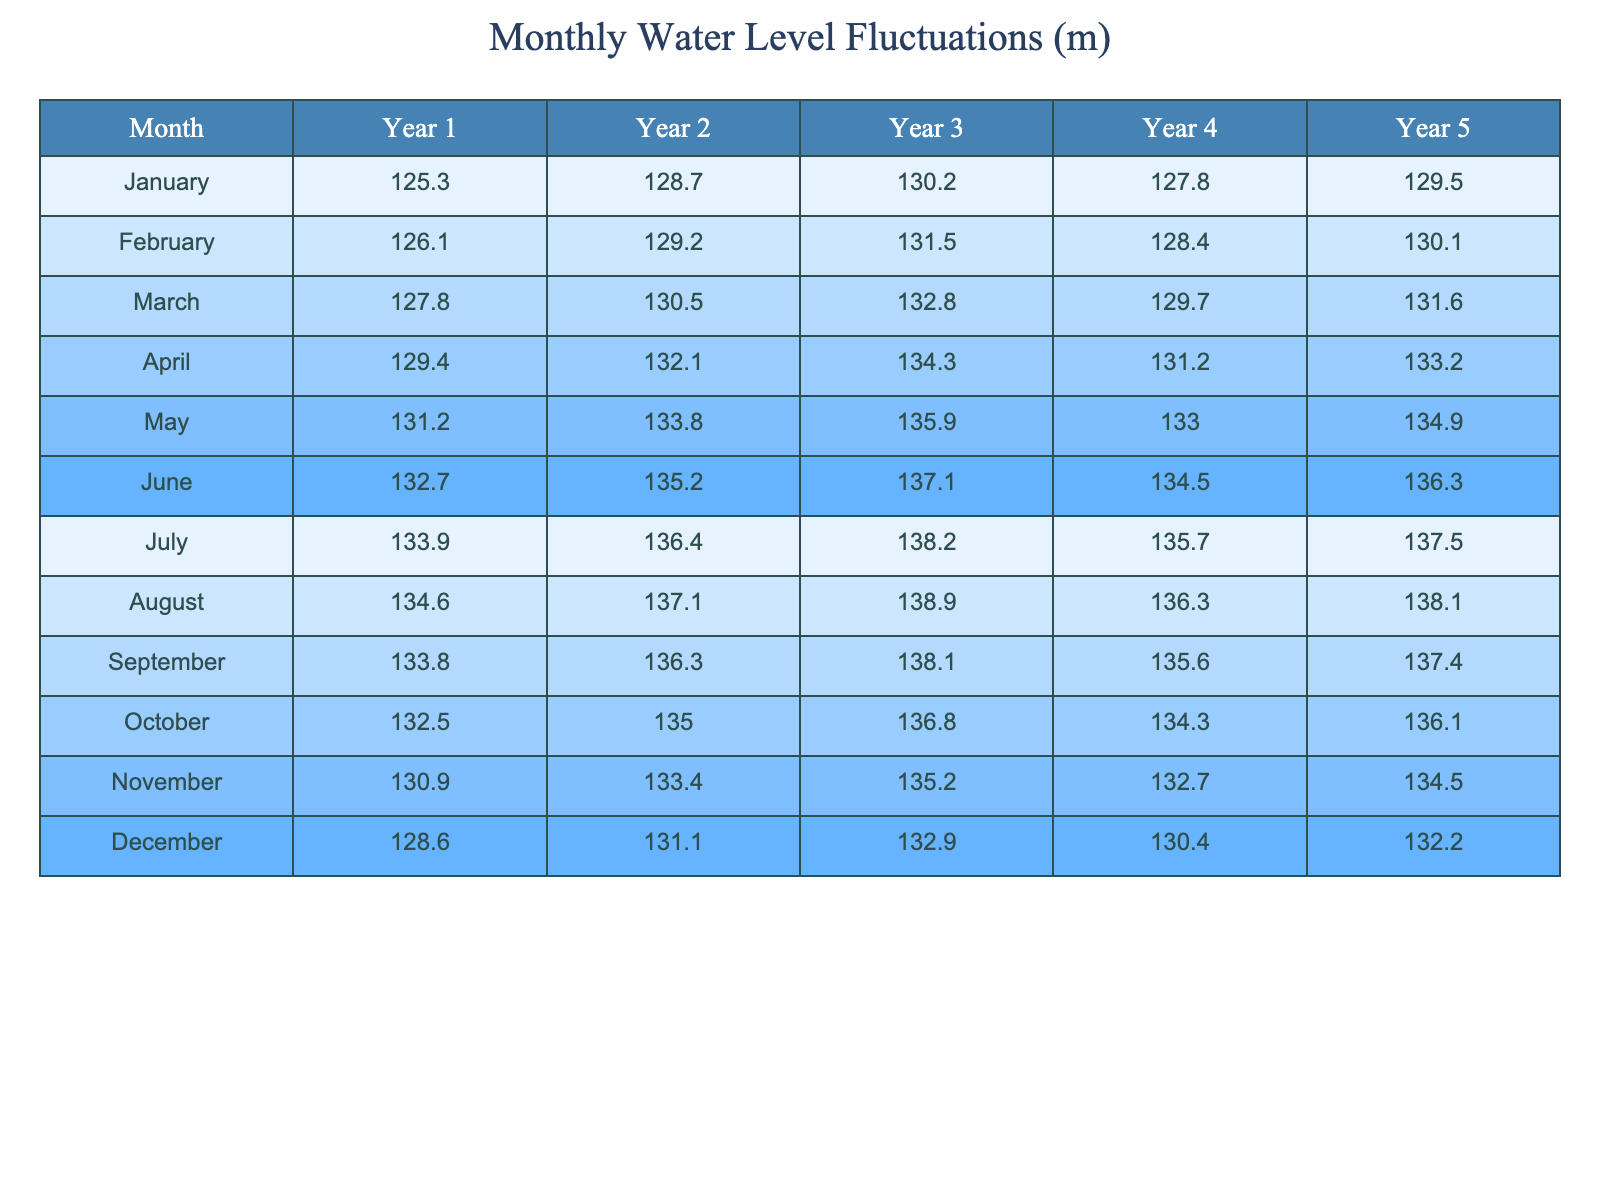What is the highest water level recorded in January over the 5-year period? Looking at the January row, the water levels for each year are 125.3, 128.7, 130.2, 127.8, and 129.5. The highest value among these is 130.2.
Answer: 130.2 What is the average water level in May across all 5 years? The May water levels across the 5 years are 131.2, 133.8, 135.9, 133.0, and 134.9. Adding these values together gives 134.1, and dividing by 5 gives an average of 134.1.
Answer: 134.1 Did the water level in July ever drop below 136 meters during the 5-year span? The levels recorded for July are 133.9, 136.4, 138.2, 135.7, and 137.5. The lowest value recorded is 133.9, which is below 136 meters, indicating that it did drop below that mark.
Answer: Yes Which month saw the greatest increase in water level from Year 1 to Year 5? By comparing the values for each month from Year 1 to Year 5, we find the increases: January (4.2), February (4.0), March (3.8), April (3.8), May (3.7), June (3.6), July (3.6), August (3.5), September (3.6), October (3.6), November (3.6), December (3.6). January had the highest increase of 4.2.
Answer: January In which year was the water level in August the highest? Observing the water levels for August, they are 134.6, 137.1, 138.9, 136.3, and 138.1 respectively for years 1 through 5. The highest value is 138.9, recorded in Year 3.
Answer: Year 3 What was the percent increase in water level from April Year 1 to April Year 5? The water levels in April for Year 1 and Year 5 were 129.4 and 133.2 respectively. The increase is 133.2 - 129.4 = 3.8. The percent increase is (3.8 / 129.4) * 100 ≈ 2.93%.
Answer: Approximately 2.93% How many months experienced a water level above 135 meters in Year 4? The recorded levels for Year 4 are: January (127.8), February (128.4), March (129.7), April (131.2), May (133.0), June (134.5), July (135.7), August (136.3), September (135.6), October (134.3), November (132.7), December (130.4). The months above 135 meters are July (135.7) and August (136.3), totaling 2 months.
Answer: 2 months What is the total water level of the reservoir for Year 2? Summing the water levels for Year 2 (128.7 + 129.2 + 130.5 + 132.1 + 133.8 + 135.2 + 136.4 + 137.1 + 136.3 + 135.0 + 133.4 + 131.1) gives a total of 1592.8.
Answer: 1592.8 In which month did the lowest water level occur in Year 5? The water levels for Year 5 show the lowest level in November, which is 134.5. The other months are higher than this value.
Answer: November 